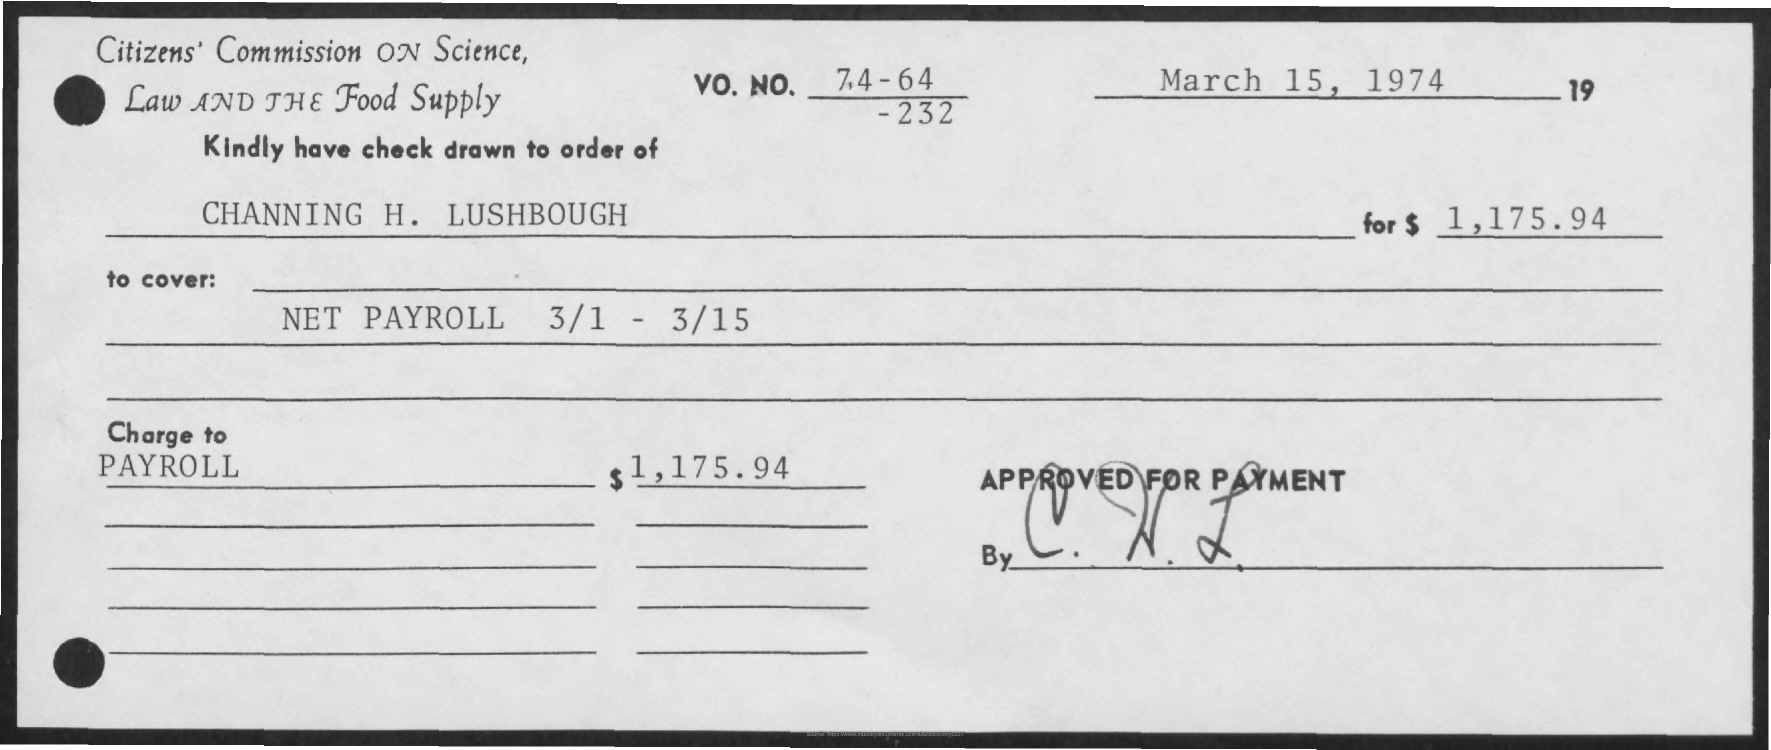What is the date mentioned ?
Give a very brief answer. March 15 , 1974. Kindly have check drawn to order of whom ?
Your response must be concise. Channing H . Lushbough . How much amount has to be payed ?
Provide a succinct answer. $ 1,175.94. 